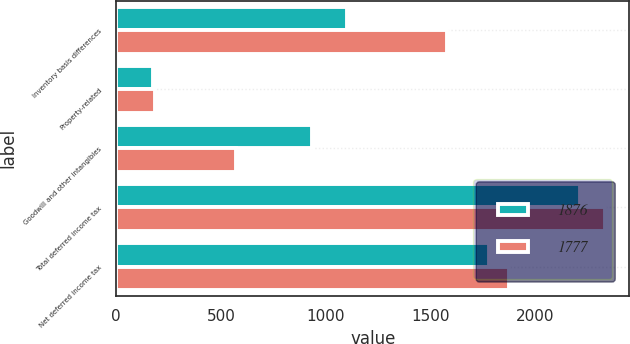Convert chart. <chart><loc_0><loc_0><loc_500><loc_500><stacked_bar_chart><ecel><fcel>Inventory basis differences<fcel>Property-related<fcel>Goodwill and other intangibles<fcel>Total deferred income tax<fcel>Net deferred income tax<nl><fcel>1876<fcel>1103<fcel>176<fcel>934<fcel>2213<fcel>1777<nl><fcel>1777<fcel>1578<fcel>183<fcel>570<fcel>2331<fcel>1876<nl></chart> 